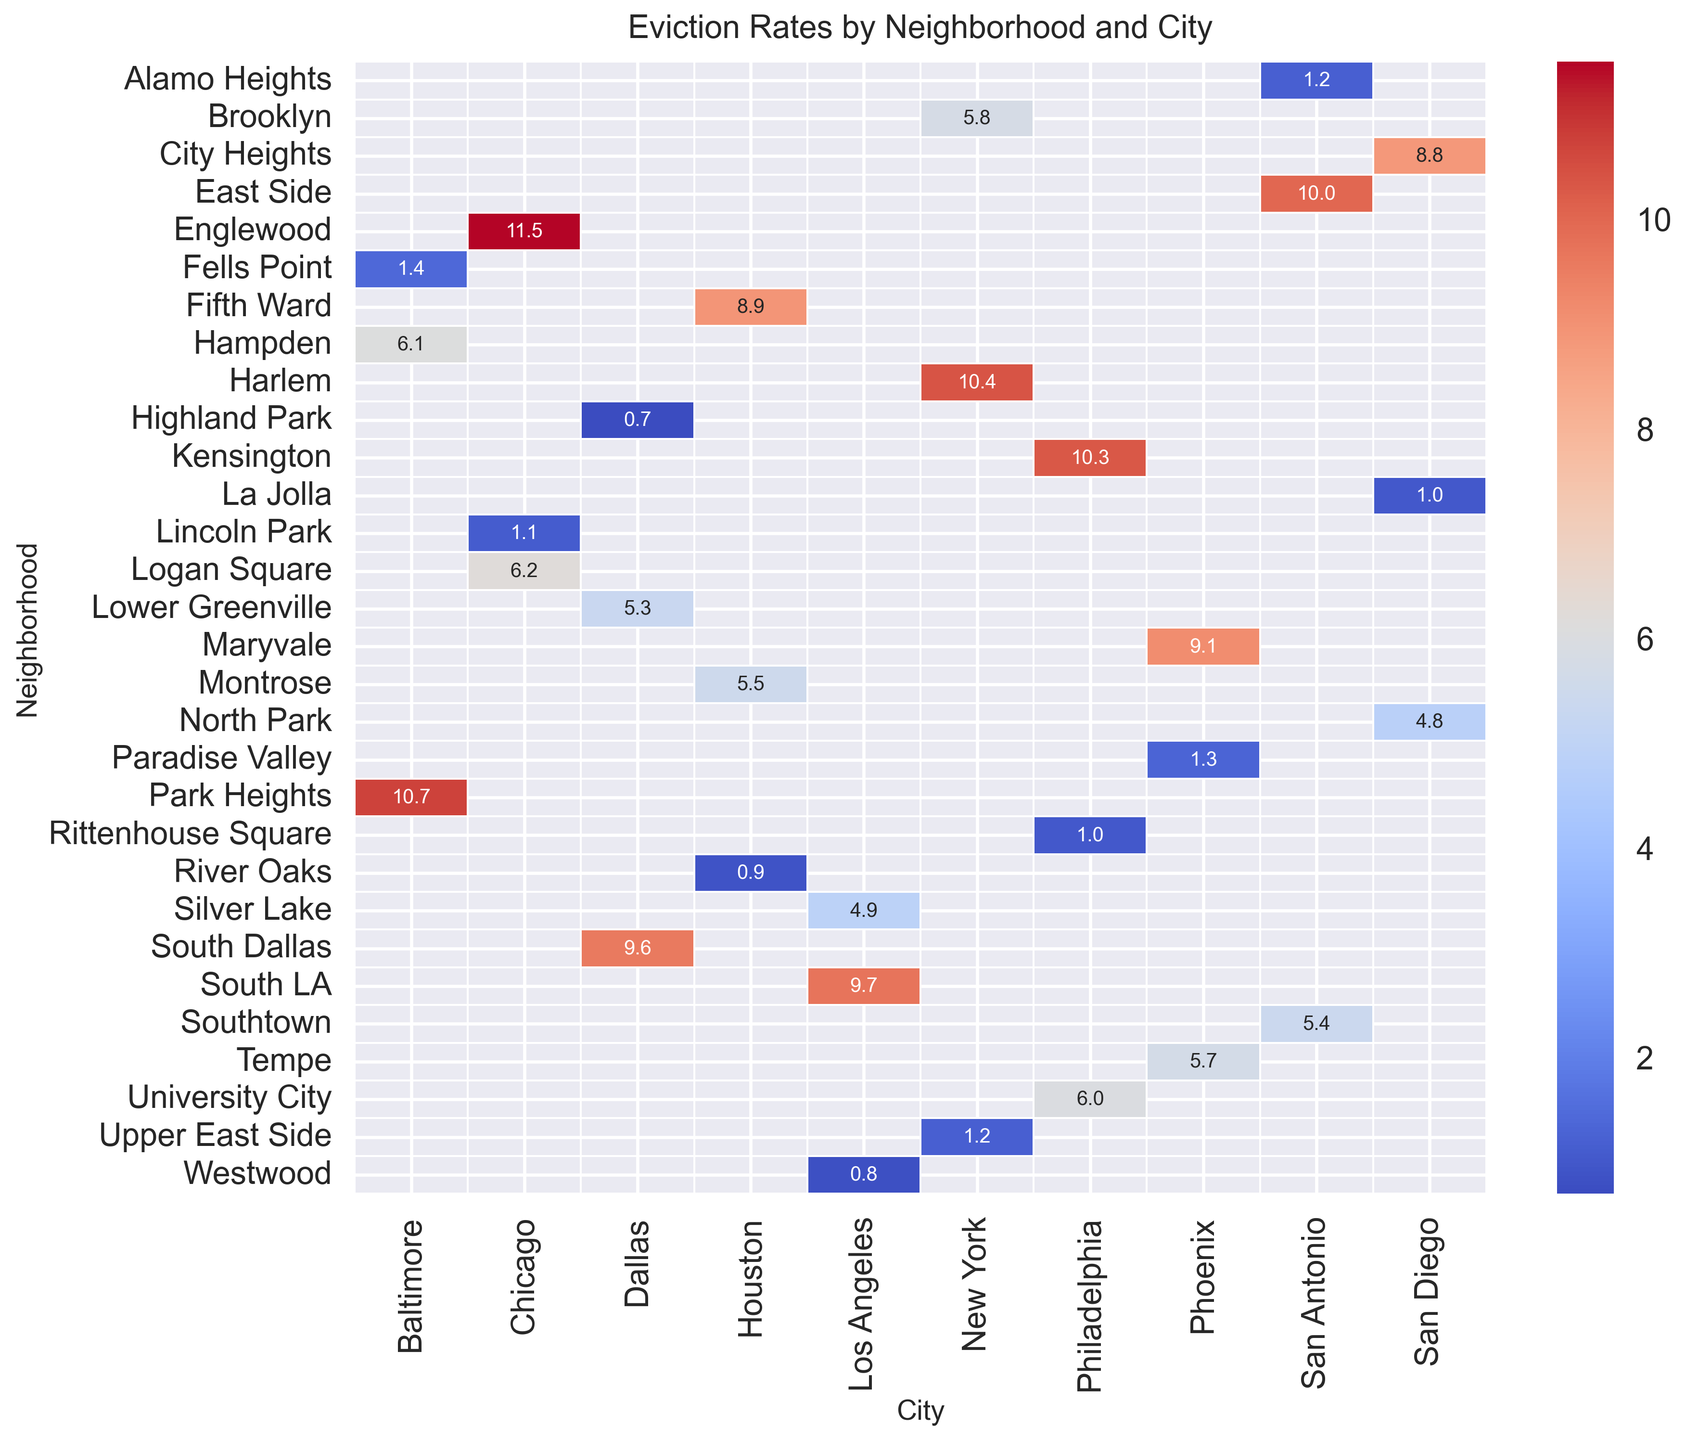Which neighborhood in San Diego has the highest eviction rate? To find the neighborhood in San Diego with the highest eviction rate, look at the column for San Diego and compare the eviction rates for the neighborhoods listed. City Heights has the highest rate at 8.8.
Answer: City Heights What is the difference in eviction rates between Harlem in New York and South LA in Los Angeles? Compare the eviction rates for Harlem (New York) and South LA (Los Angeles). The rate for Harlem is 10.4 and for South LA is 9.7. The difference is 10.4 - 9.7 = 0.7.
Answer: 0.7 Which city has the neighborhood with the highest eviction rate overall? Scan the heatmap to find the highest eviction rate overall, which is in Englewood (Chicago) with a rate of 11.5.
Answer: Chicago What is the average eviction rate for neighborhoods with medium income levels in the entire dataset? To find the average, sum the eviction rates of all medium income neighborhoods (Brooklyn 5.8, Silver Lake 4.9, Logan Square 6.2, Montrose 5.5, University City 6.0, Tempe 5.7, Southtown 5.4, Lower Greenville 5.3, North Park 4.8, Hampden 6.1) and divide by the number of neighborhoods. The total is 56.7 and the average is 56.7 / 10 = 5.67.
Answer: 5.67 How does the eviction rate in River Oaks (Houston) compare to Alamo Heights (San Antonio)? Compare the eviction rates between River Oaks (Houston) and Alamo Heights (San Antonio). Both neighborhoods have an eviction rate of 1.2.
Answer: Equal What is the median eviction rate among all high-income neighborhoods? List the eviction rates for high-income neighborhoods (Upper East Side 1.2, Westwood 0.8, Lincoln Park 1.1, River Oaks 0.9, Rittenhouse Square 1.0, Paradise Valley 1.3, Alamo Heights 1.2, Highland Park 0.7, La Jolla 1.0, Fells Point 1.4), sort them (0.7, 0.8, 0.9, 1.0, 1.0, 1.1, 1.2, 1.2, 1.3, 1.4), and find the middle value. For an even number of data points, the median is the average of the 5th and 6th values. Thus, median is (1.0 + 1.1) / 2 = 1.05.
Answer: 1.05 Which city has the most variation in eviction rates among its neighborhoods? To determine the city with the most variation, observe the highest and lowest eviction rates in each city's column. Chicago has the highest variation with Englewood (11.5) and Lincoln Park (1.1), making the range 10.4.
Answer: Chicago 